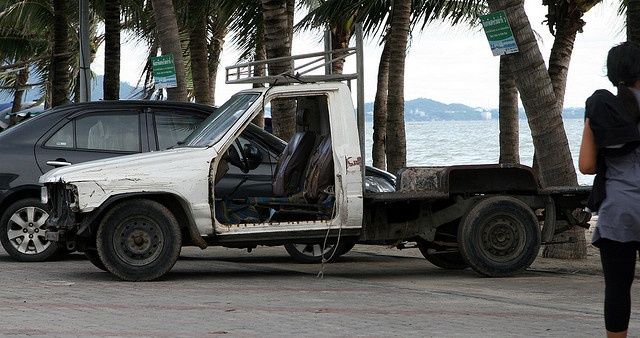Describe the objects in this image and their specific colors. I can see truck in darkgreen, black, lightgray, gray, and darkgray tones, car in darkgreen, black, gray, darkblue, and darkgray tones, and people in darkgreen, black, gray, and maroon tones in this image. 